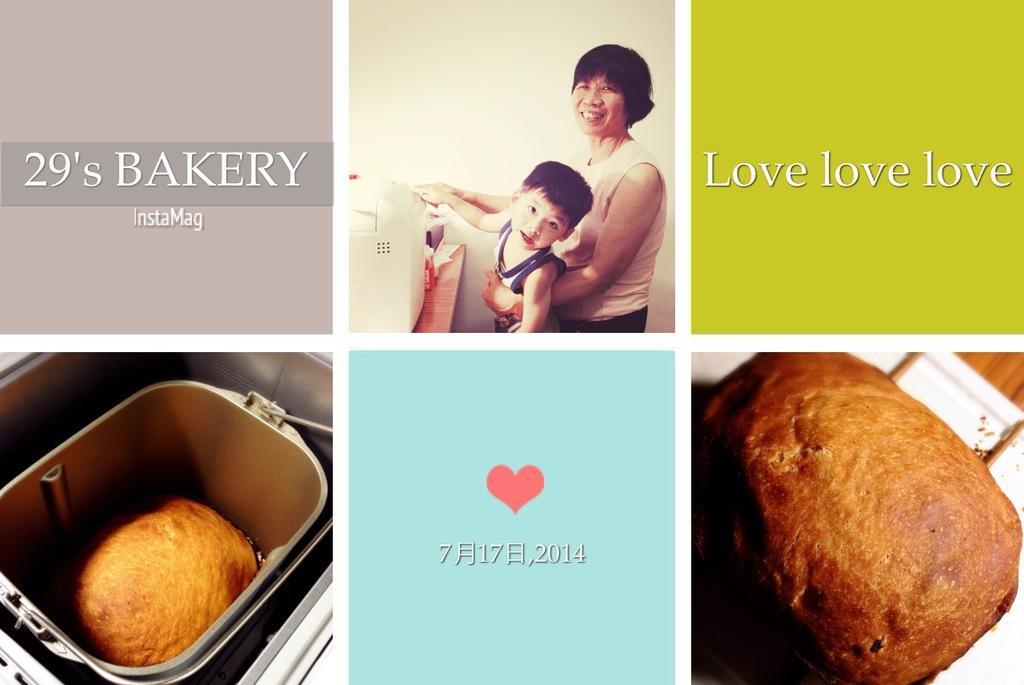Describe this image in one or two sentences. This image is a collage of different pictures. In which a woman is holding a boy in her hand. To the left side we can see a food in a bowl. to the right side we can see food placed on the table. 